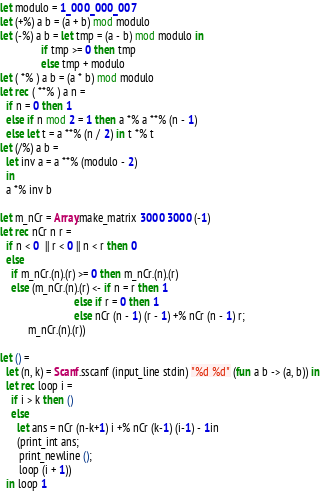Convert code to text. <code><loc_0><loc_0><loc_500><loc_500><_OCaml_>let modulo = 1_000_000_007
let (+%) a b = (a + b) mod modulo
let (-%) a b = let tmp = (a - b) mod modulo in
               if tmp >= 0 then tmp
               else tmp + modulo
let ( *% ) a b = (a * b) mod modulo
let rec ( **% ) a n =
  if n = 0 then 1
  else if n mod 2 = 1 then a *% a **% (n - 1)
  else let t = a **% (n / 2) in t *% t
let (/%) a b =
  let inv a = a **% (modulo - 2)
  in
  a *% inv b

let m_nCr = Array.make_matrix 3000 3000 (-1)
let rec nCr n r =
  if n < 0  || r < 0 || n < r then 0
  else
    if m_nCr.(n).(r) >= 0 then m_nCr.(n).(r)
    else (m_nCr.(n).(r) <- if n = r then 1
                           else if r = 0 then 1
                           else nCr (n - 1) (r - 1) +% nCr (n - 1) r;
          m_nCr.(n).(r))
  
let () =
  let (n, k) = Scanf.sscanf (input_line stdin) "%d %d" (fun a b -> (a, b)) in
  let rec loop i =
    if i > k then ()
    else
      let ans = nCr (n-k+1) i +% nCr (k-1) (i-1) - 1in
      (print_int ans;
       print_newline ();
       loop (i + 1))
  in loop 1
    
</code> 